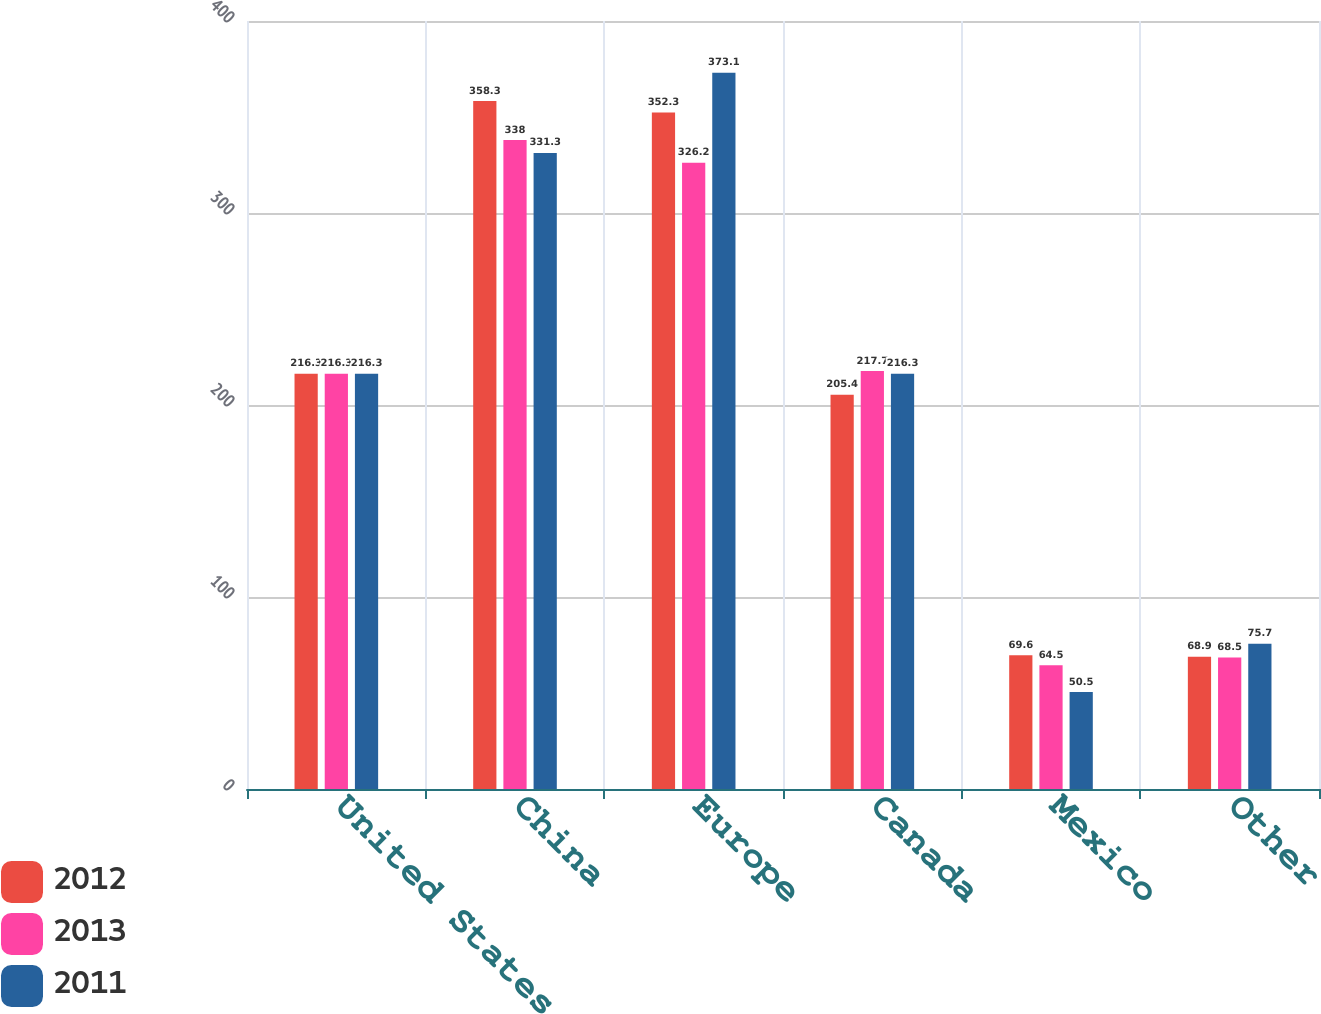Convert chart to OTSL. <chart><loc_0><loc_0><loc_500><loc_500><stacked_bar_chart><ecel><fcel>United States<fcel>China<fcel>Europe<fcel>Canada<fcel>Mexico<fcel>Other<nl><fcel>2012<fcel>216.3<fcel>358.3<fcel>352.3<fcel>205.4<fcel>69.6<fcel>68.9<nl><fcel>2013<fcel>216.3<fcel>338<fcel>326.2<fcel>217.7<fcel>64.5<fcel>68.5<nl><fcel>2011<fcel>216.3<fcel>331.3<fcel>373.1<fcel>216.3<fcel>50.5<fcel>75.7<nl></chart> 